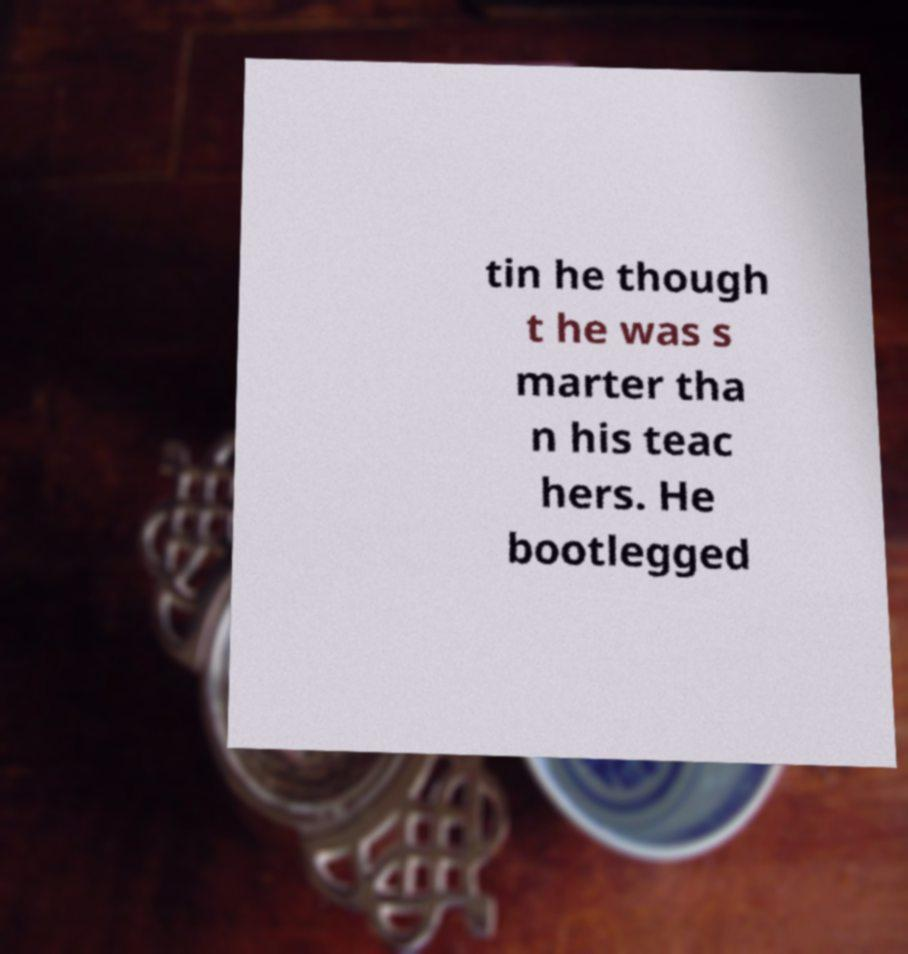Could you extract and type out the text from this image? tin he though t he was s marter tha n his teac hers. He bootlegged 